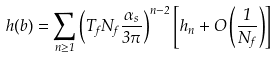<formula> <loc_0><loc_0><loc_500><loc_500>h ( b ) = \sum _ { n \geq 1 } \left ( T _ { f } N _ { f } \frac { \alpha _ { s } } { 3 \pi } \right ) ^ { n - 2 } \left [ h _ { n } + O \left ( \frac { 1 } { N _ { f } } \right ) \right ]</formula> 